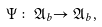<formula> <loc_0><loc_0><loc_500><loc_500>\Psi \colon \mathfrak { A } _ { b } \mathfrak { \rightarrow A } _ { b } ,</formula> 